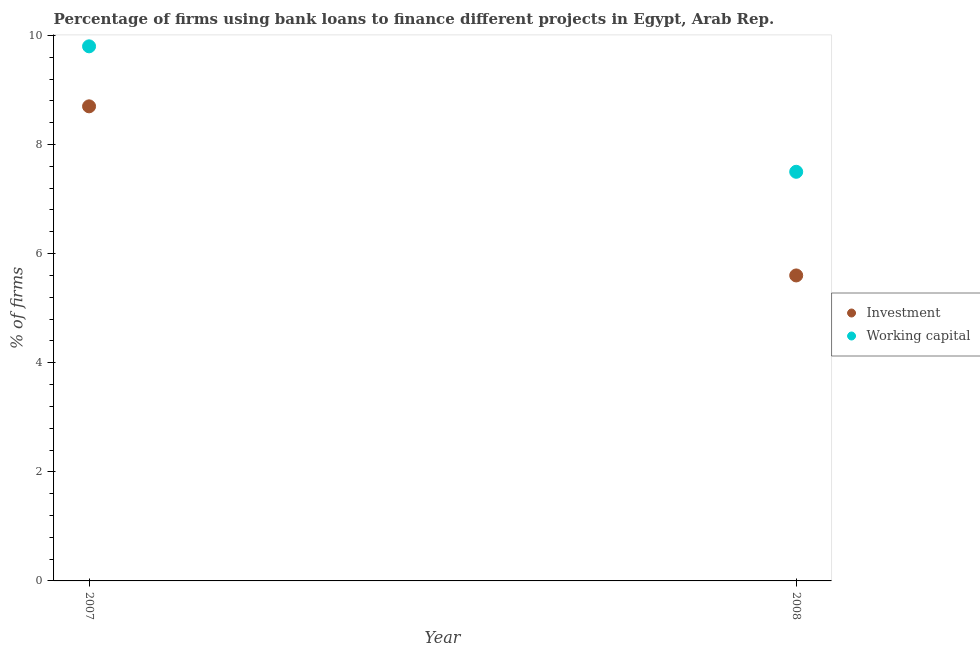Across all years, what is the minimum percentage of firms using banks to finance investment?
Your answer should be compact. 5.6. What is the total percentage of firms using banks to finance working capital in the graph?
Offer a very short reply. 17.3. What is the difference between the percentage of firms using banks to finance investment in 2007 and that in 2008?
Ensure brevity in your answer.  3.1. What is the difference between the percentage of firms using banks to finance investment in 2007 and the percentage of firms using banks to finance working capital in 2008?
Your answer should be very brief. 1.2. What is the average percentage of firms using banks to finance working capital per year?
Your answer should be very brief. 8.65. In the year 2008, what is the difference between the percentage of firms using banks to finance working capital and percentage of firms using banks to finance investment?
Your answer should be compact. 1.9. In how many years, is the percentage of firms using banks to finance investment greater than 6.8 %?
Offer a terse response. 1. What is the ratio of the percentage of firms using banks to finance investment in 2007 to that in 2008?
Your answer should be very brief. 1.55. Is the percentage of firms using banks to finance investment in 2007 less than that in 2008?
Offer a terse response. No. Is the percentage of firms using banks to finance working capital strictly greater than the percentage of firms using banks to finance investment over the years?
Ensure brevity in your answer.  Yes. Is the percentage of firms using banks to finance working capital strictly less than the percentage of firms using banks to finance investment over the years?
Your answer should be very brief. No. How many dotlines are there?
Provide a succinct answer. 2. Are the values on the major ticks of Y-axis written in scientific E-notation?
Provide a succinct answer. No. Does the graph contain grids?
Provide a short and direct response. No. How many legend labels are there?
Ensure brevity in your answer.  2. What is the title of the graph?
Offer a terse response. Percentage of firms using bank loans to finance different projects in Egypt, Arab Rep. Does "Netherlands" appear as one of the legend labels in the graph?
Offer a terse response. No. What is the label or title of the Y-axis?
Give a very brief answer. % of firms. What is the % of firms of Investment in 2007?
Your response must be concise. 8.7. What is the % of firms in Working capital in 2008?
Your response must be concise. 7.5. Across all years, what is the minimum % of firms in Working capital?
Make the answer very short. 7.5. What is the average % of firms of Investment per year?
Provide a succinct answer. 7.15. What is the average % of firms of Working capital per year?
Ensure brevity in your answer.  8.65. In the year 2007, what is the difference between the % of firms of Investment and % of firms of Working capital?
Give a very brief answer. -1.1. In the year 2008, what is the difference between the % of firms of Investment and % of firms of Working capital?
Make the answer very short. -1.9. What is the ratio of the % of firms of Investment in 2007 to that in 2008?
Keep it short and to the point. 1.55. What is the ratio of the % of firms of Working capital in 2007 to that in 2008?
Provide a short and direct response. 1.31. What is the difference between the highest and the lowest % of firms of Investment?
Your answer should be compact. 3.1. 